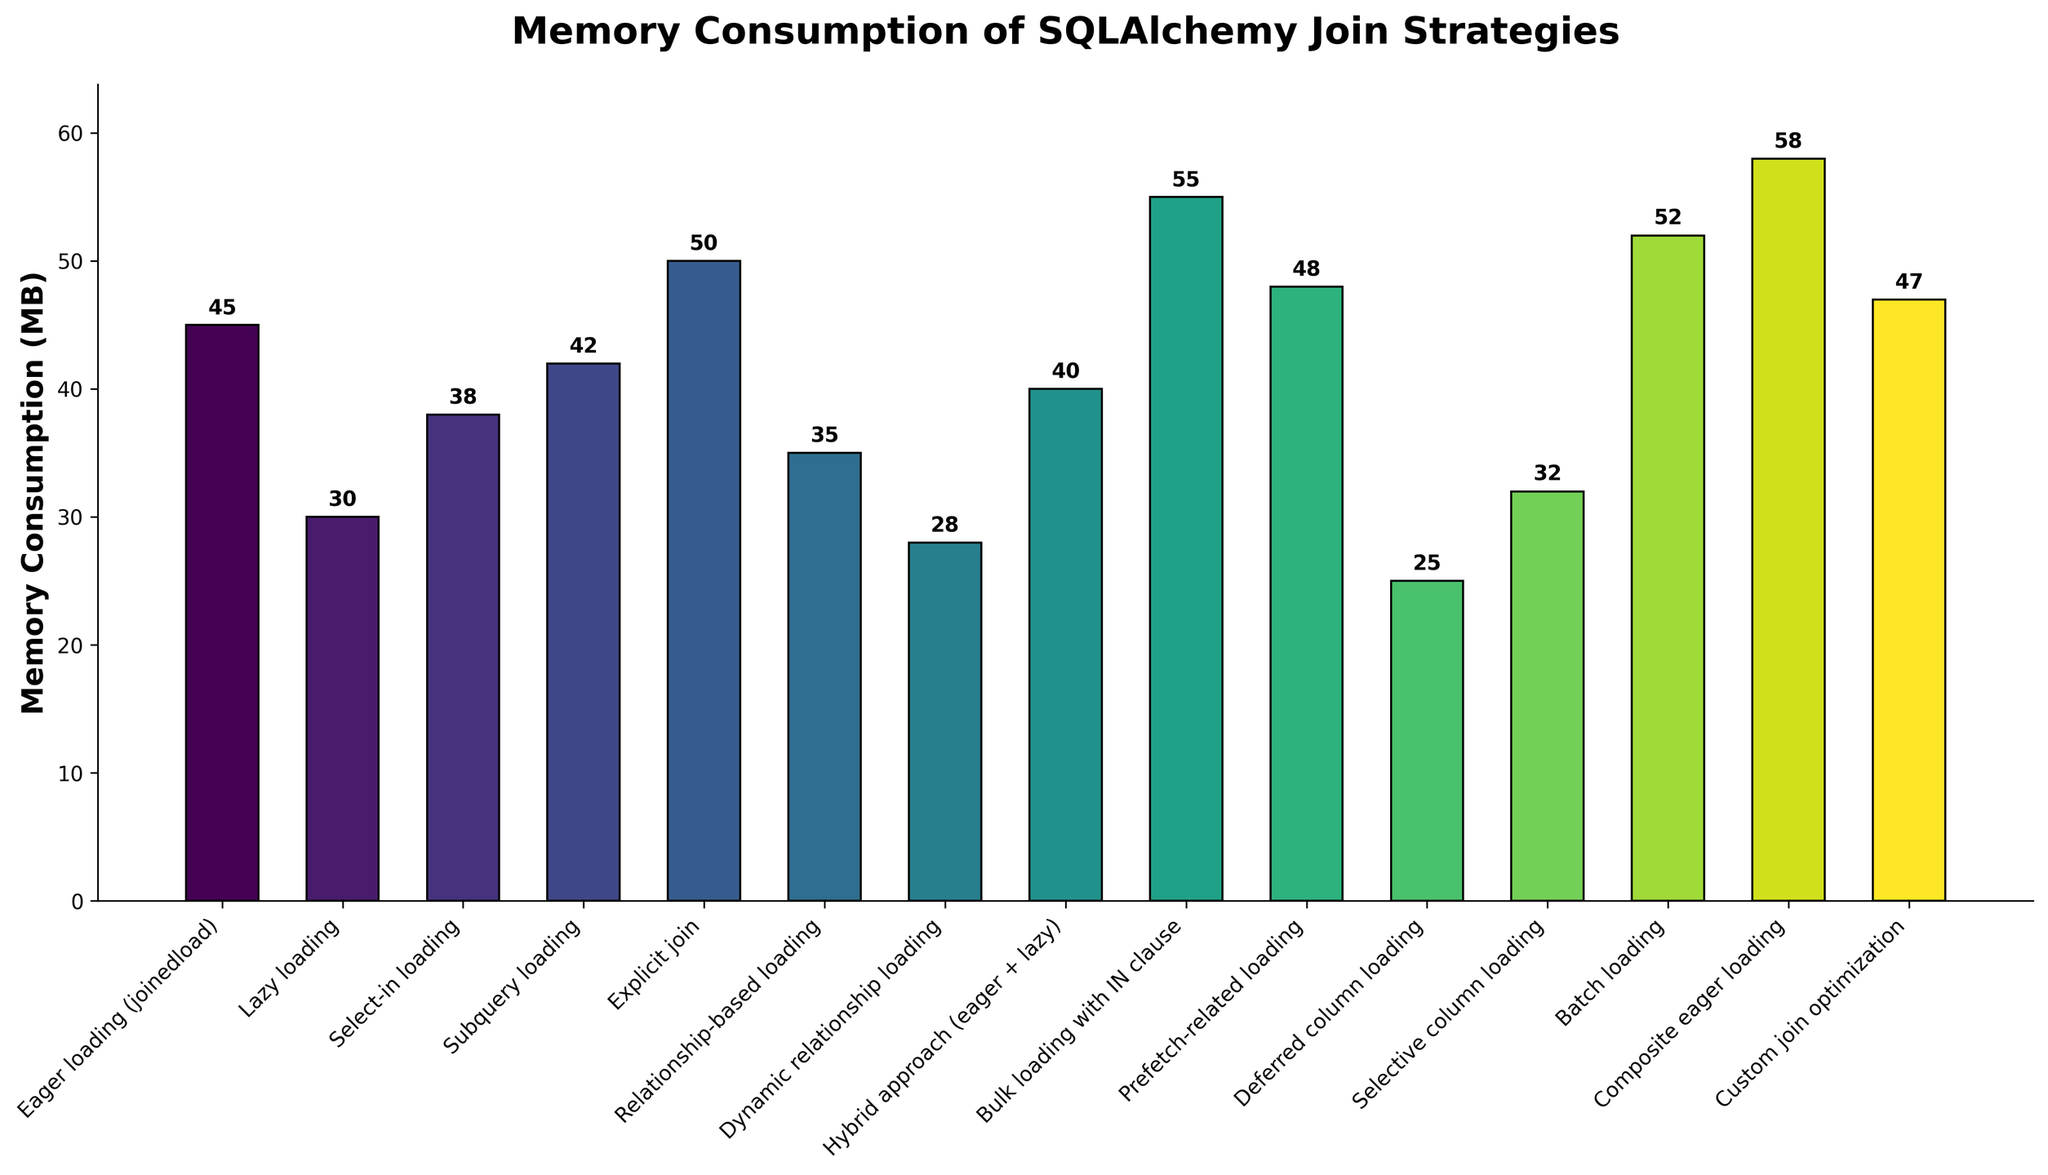Which SQLAlchemy join strategy has the highest memory consumption? The bar representing "Composite eager loading" is the tallest, indicating it uses the most memory.
Answer: Composite eager loading Which SQLAlchemy join strategy consumes less memory, Lazy loading or Relationship-based loading? Comparing the bars, Lazy loading (30 MB) is shorter than Relationship-based loading (35 MB), so it consumes less memory.
Answer: Lazy loading What's the total memory consumption of the top three most memory-intensive strategies? The top three are Composite eager loading, Bulk loading with IN clause, and Batch loading, consuming 58 MB, 55 MB, and 52 MB respectively. Summing these gives 58 + 55 + 52 = 165 MB.
Answer: 165 MB Which strategy has the lowest memory consumption, and how much is it? The bar for "Deferred column loading" is the shortest, indicating the lowest memory consumption of 25 MB.
Answer: Deferred column loading, 25 MB How much more memory does an Explicit join consume compared to Lazy loading? Explicit join consumes 50 MB, while Lazy loading consumes 30 MB. The difference is 50 - 30 = 20 MB.
Answer: 20 MB What's the average memory consumption of all the strategies? Sum all memory consumptions (45 + 30 + 38 + 42 + 50 + 35 + 28 + 40 + 55 + 48 + 25 + 32 + 52 + 58 + 47) = 625 MB. Divide by the number of strategies (15): 625 / 15 ≈ 41.67 MB.
Answer: ~41.67 MB Which two strategies have a combined memory consumption exactly equal to Explicit join? Explicit join uses 50 MB. Lazy loading (30 MB) and Selective column loading (32 MB) combine to 30 + 32 = 62 MB, not equal. Dynamic relationship loading (28 MB) and Relationship-based loading (35 MB) combine to 28 + 35 = 63 MB, still not equal. Hybrid approach (40 MB) and Lazy loading (30 MB) combine to 40 + 30 = 70 MB, not equal. Lazy loading (30 MB) and Relationship-based loading (35 MB) combine to 30 + 35 = 65 MB, closer but not exact. Explicit join uniquely stands isolated with no pair.
Answer: None Given the various strategies, how many strategies consume below 40 MB of memory? Visually, the bars for "Lazy loading," "Relationship-based loading," "Dynamic relationship loading," "Deferred column loading," and "Selective column loading" are below 40 MB. Counting these gives 5.
Answer: 5 